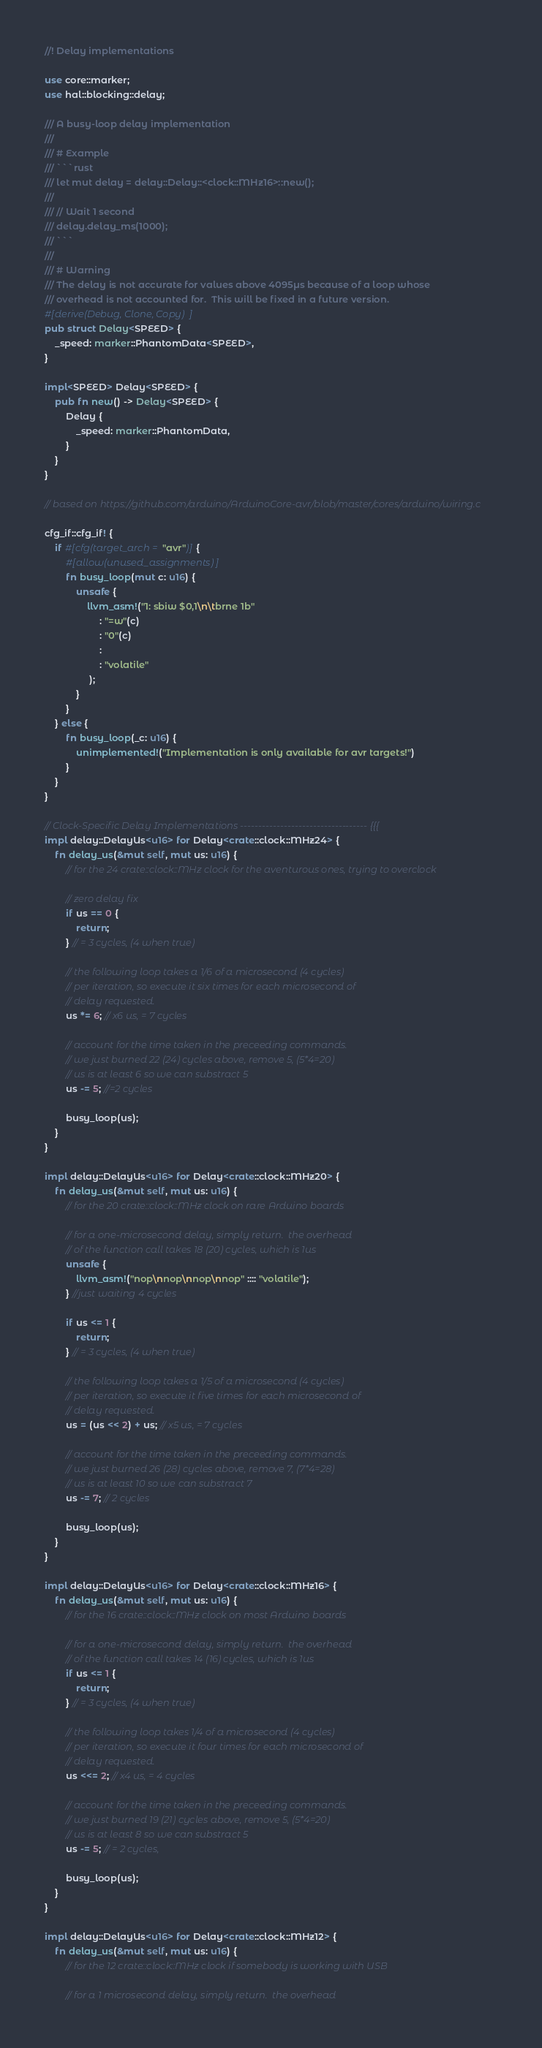<code> <loc_0><loc_0><loc_500><loc_500><_Rust_>//! Delay implementations

use core::marker;
use hal::blocking::delay;

/// A busy-loop delay implementation
///
/// # Example
/// ```rust
/// let mut delay = delay::Delay::<clock::MHz16>::new();
///
/// // Wait 1 second
/// delay.delay_ms(1000);
/// ```
///
/// # Warning
/// The delay is not accurate for values above 4095µs because of a loop whose
/// overhead is not accounted for.  This will be fixed in a future version.
#[derive(Debug, Clone, Copy)]
pub struct Delay<SPEED> {
    _speed: marker::PhantomData<SPEED>,
}

impl<SPEED> Delay<SPEED> {
    pub fn new() -> Delay<SPEED> {
        Delay {
            _speed: marker::PhantomData,
        }
    }
}

// based on https://github.com/arduino/ArduinoCore-avr/blob/master/cores/arduino/wiring.c

cfg_if::cfg_if! {
    if #[cfg(target_arch = "avr")] {
        #[allow(unused_assignments)]
        fn busy_loop(mut c: u16) {
            unsafe {
                llvm_asm!("1: sbiw $0,1\n\tbrne 1b"
                     : "=w"(c)
                     : "0"(c)
                     :
                     : "volatile"
                 );
            }
        }
    } else {
        fn busy_loop(_c: u16) {
            unimplemented!("Implementation is only available for avr targets!")
        }
    }
}

// Clock-Specific Delay Implementations ----------------------------------- {{{
impl delay::DelayUs<u16> for Delay<crate::clock::MHz24> {
    fn delay_us(&mut self, mut us: u16) {
        // for the 24 crate::clock::MHz clock for the aventurous ones, trying to overclock

        // zero delay fix
        if us == 0 {
            return;
        } // = 3 cycles, (4 when true)

        // the following loop takes a 1/6 of a microsecond (4 cycles)
        // per iteration, so execute it six times for each microsecond of
        // delay requested.
        us *= 6; // x6 us, = 7 cycles

        // account for the time taken in the preceeding commands.
        // we just burned 22 (24) cycles above, remove 5, (5*4=20)
        // us is at least 6 so we can substract 5
        us -= 5; //=2 cycles

        busy_loop(us);
    }
}

impl delay::DelayUs<u16> for Delay<crate::clock::MHz20> {
    fn delay_us(&mut self, mut us: u16) {
        // for the 20 crate::clock::MHz clock on rare Arduino boards

        // for a one-microsecond delay, simply return.  the overhead
        // of the function call takes 18 (20) cycles, which is 1us
        unsafe {
            llvm_asm!("nop\nnop\nnop\nnop" :::: "volatile");
        } //just waiting 4 cycles

        if us <= 1 {
            return;
        } // = 3 cycles, (4 when true)

        // the following loop takes a 1/5 of a microsecond (4 cycles)
        // per iteration, so execute it five times for each microsecond of
        // delay requested.
        us = (us << 2) + us; // x5 us, = 7 cycles

        // account for the time taken in the preceeding commands.
        // we just burned 26 (28) cycles above, remove 7, (7*4=28)
        // us is at least 10 so we can substract 7
        us -= 7; // 2 cycles

        busy_loop(us);
    }
}

impl delay::DelayUs<u16> for Delay<crate::clock::MHz16> {
    fn delay_us(&mut self, mut us: u16) {
        // for the 16 crate::clock::MHz clock on most Arduino boards

        // for a one-microsecond delay, simply return.  the overhead
        // of the function call takes 14 (16) cycles, which is 1us
        if us <= 1 {
            return;
        } // = 3 cycles, (4 when true)

        // the following loop takes 1/4 of a microsecond (4 cycles)
        // per iteration, so execute it four times for each microsecond of
        // delay requested.
        us <<= 2; // x4 us, = 4 cycles

        // account for the time taken in the preceeding commands.
        // we just burned 19 (21) cycles above, remove 5, (5*4=20)
        // us is at least 8 so we can substract 5
        us -= 5; // = 2 cycles,

        busy_loop(us);
    }
}

impl delay::DelayUs<u16> for Delay<crate::clock::MHz12> {
    fn delay_us(&mut self, mut us: u16) {
        // for the 12 crate::clock::MHz clock if somebody is working with USB

        // for a 1 microsecond delay, simply return.  the overhead</code> 